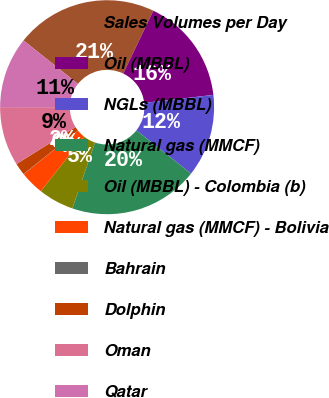<chart> <loc_0><loc_0><loc_500><loc_500><pie_chart><fcel>Sales Volumes per Day<fcel>Oil (MBBL)<fcel>NGLs (MBBL)<fcel>Natural gas (MMCF)<fcel>Oil (MBBL) - Colombia (b)<fcel>Natural gas (MMCF) - Bolivia<fcel>Bahrain<fcel>Dolphin<fcel>Oman<fcel>Qatar<nl><fcel>21.39%<fcel>16.05%<fcel>12.49%<fcel>19.61%<fcel>5.37%<fcel>3.59%<fcel>0.04%<fcel>1.81%<fcel>8.93%<fcel>10.71%<nl></chart> 